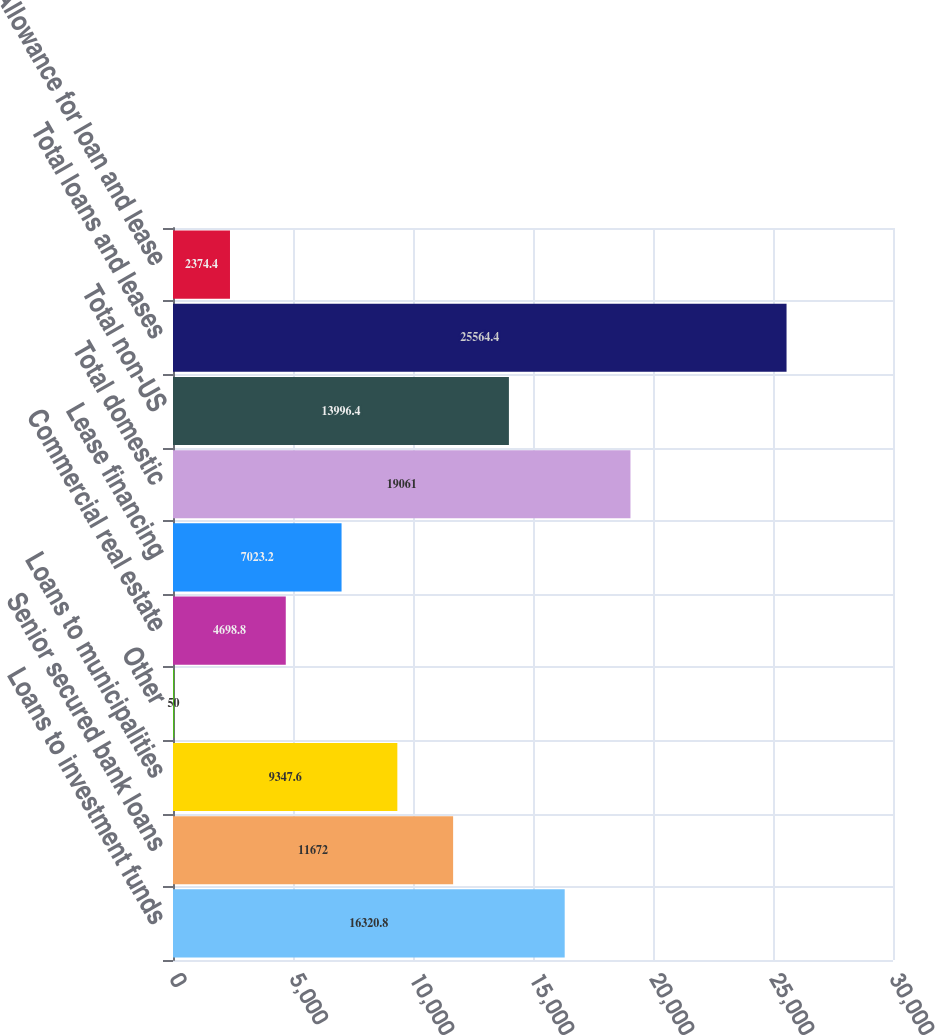Convert chart to OTSL. <chart><loc_0><loc_0><loc_500><loc_500><bar_chart><fcel>Loans to investment funds<fcel>Senior secured bank loans<fcel>Loans to municipalities<fcel>Other<fcel>Commercial real estate<fcel>Lease financing<fcel>Total domestic<fcel>Total non-US<fcel>Total loans and leases<fcel>Allowance for loan and lease<nl><fcel>16320.8<fcel>11672<fcel>9347.6<fcel>50<fcel>4698.8<fcel>7023.2<fcel>19061<fcel>13996.4<fcel>25564.4<fcel>2374.4<nl></chart> 